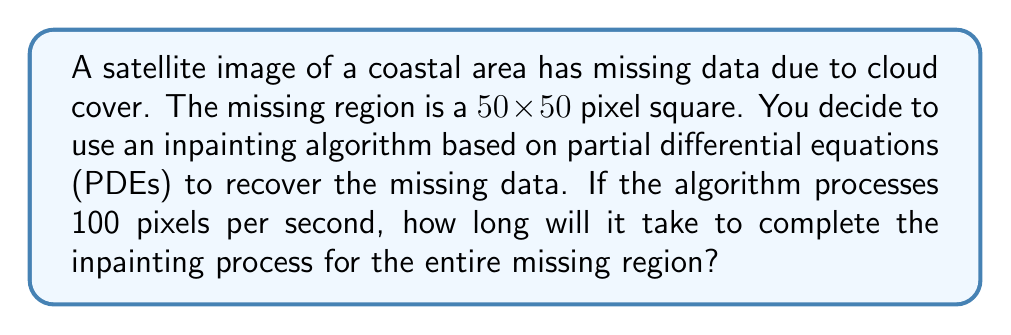What is the answer to this math problem? To solve this problem, we need to follow these steps:

1. Calculate the total number of pixels in the missing region:
   The missing region is a $50 \times 50$ pixel square.
   Total pixels = $50 \times 50 = 2500$ pixels

2. Determine the processing rate:
   The algorithm processes 100 pixels per second.

3. Calculate the time needed to process all pixels:
   Time = Total pixels ÷ Processing rate
   Time = $2500 \div 100 = 25$ seconds

Therefore, it will take 25 seconds to complete the inpainting process for the entire missing region.

This question is relevant to remote ICT teaching as it combines image processing concepts with basic mathematical operations, allowing students to understand the practical applications of algorithms in real-world scenarios like satellite image reconstruction.
Answer: 25 seconds 